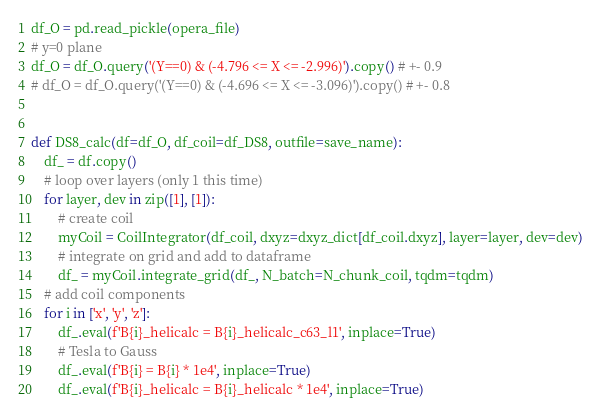<code> <loc_0><loc_0><loc_500><loc_500><_Python_>df_O = pd.read_pickle(opera_file)
# y=0 plane
df_O = df_O.query('(Y==0) & (-4.796 <= X <= -2.996)').copy() # +- 0.9
# df_O = df_O.query('(Y==0) & (-4.696 <= X <= -3.096)').copy() # +- 0.8


def DS8_calc(df=df_O, df_coil=df_DS8, outfile=save_name):
    df_ = df.copy()
    # loop over layers (only 1 this time)
    for layer, dev in zip([1], [1]):
        # create coil
        myCoil = CoilIntegrator(df_coil, dxyz=dxyz_dict[df_coil.dxyz], layer=layer, dev=dev)
        # integrate on grid and add to dataframe
        df_ = myCoil.integrate_grid(df_, N_batch=N_chunk_coil, tqdm=tqdm)
    # add coil components
    for i in ['x', 'y', 'z']:
        df_.eval(f'B{i}_helicalc = B{i}_helicalc_c63_l1', inplace=True)
        # Tesla to Gauss
        df_.eval(f'B{i} = B{i} * 1e4', inplace=True)
        df_.eval(f'B{i}_helicalc = B{i}_helicalc * 1e4', inplace=True)</code> 